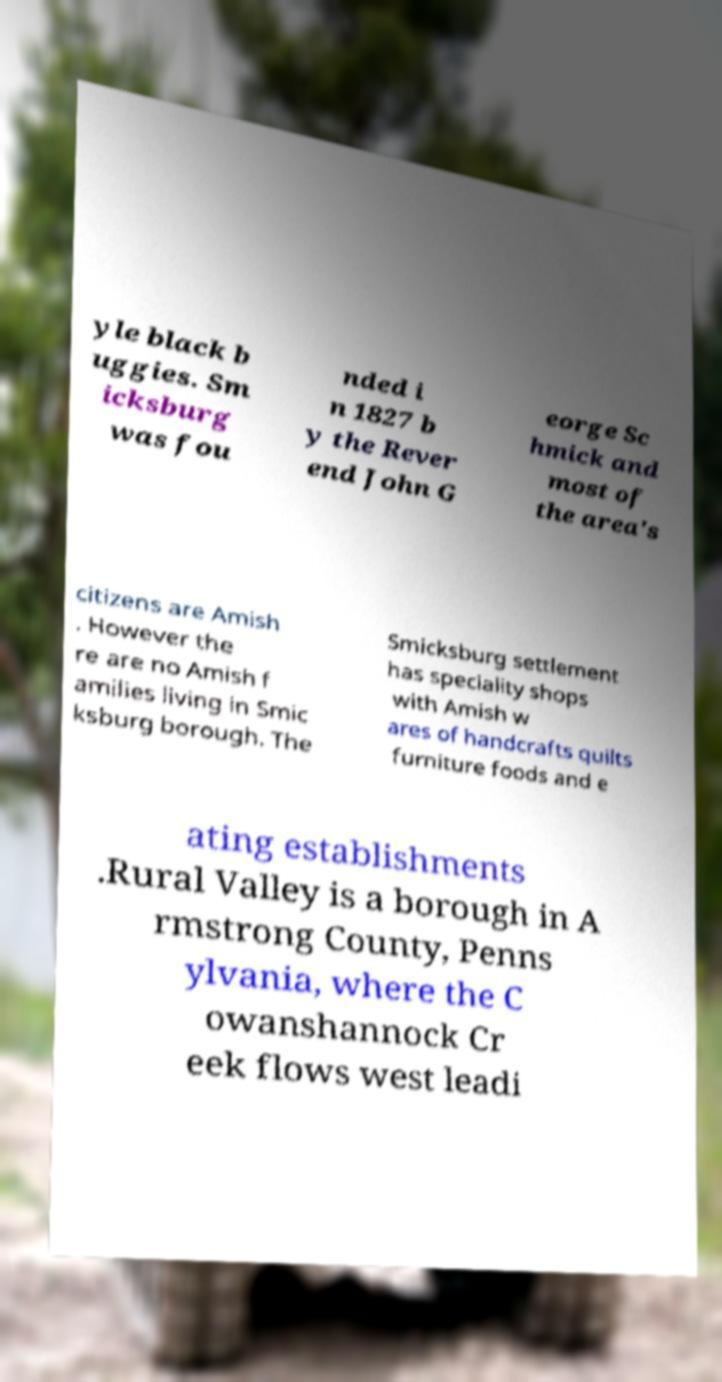I need the written content from this picture converted into text. Can you do that? yle black b uggies. Sm icksburg was fou nded i n 1827 b y the Rever end John G eorge Sc hmick and most of the area's citizens are Amish . However the re are no Amish f amilies living in Smic ksburg borough. The Smicksburg settlement has speciality shops with Amish w ares of handcrafts quilts furniture foods and e ating establishments .Rural Valley is a borough in A rmstrong County, Penns ylvania, where the C owanshannock Cr eek flows west leadi 